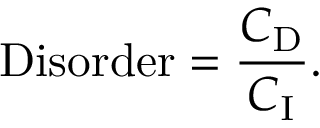Convert formula to latex. <formula><loc_0><loc_0><loc_500><loc_500>{ D i s o r d e r } = { \frac { C _ { D } } { C _ { I } } } .</formula> 